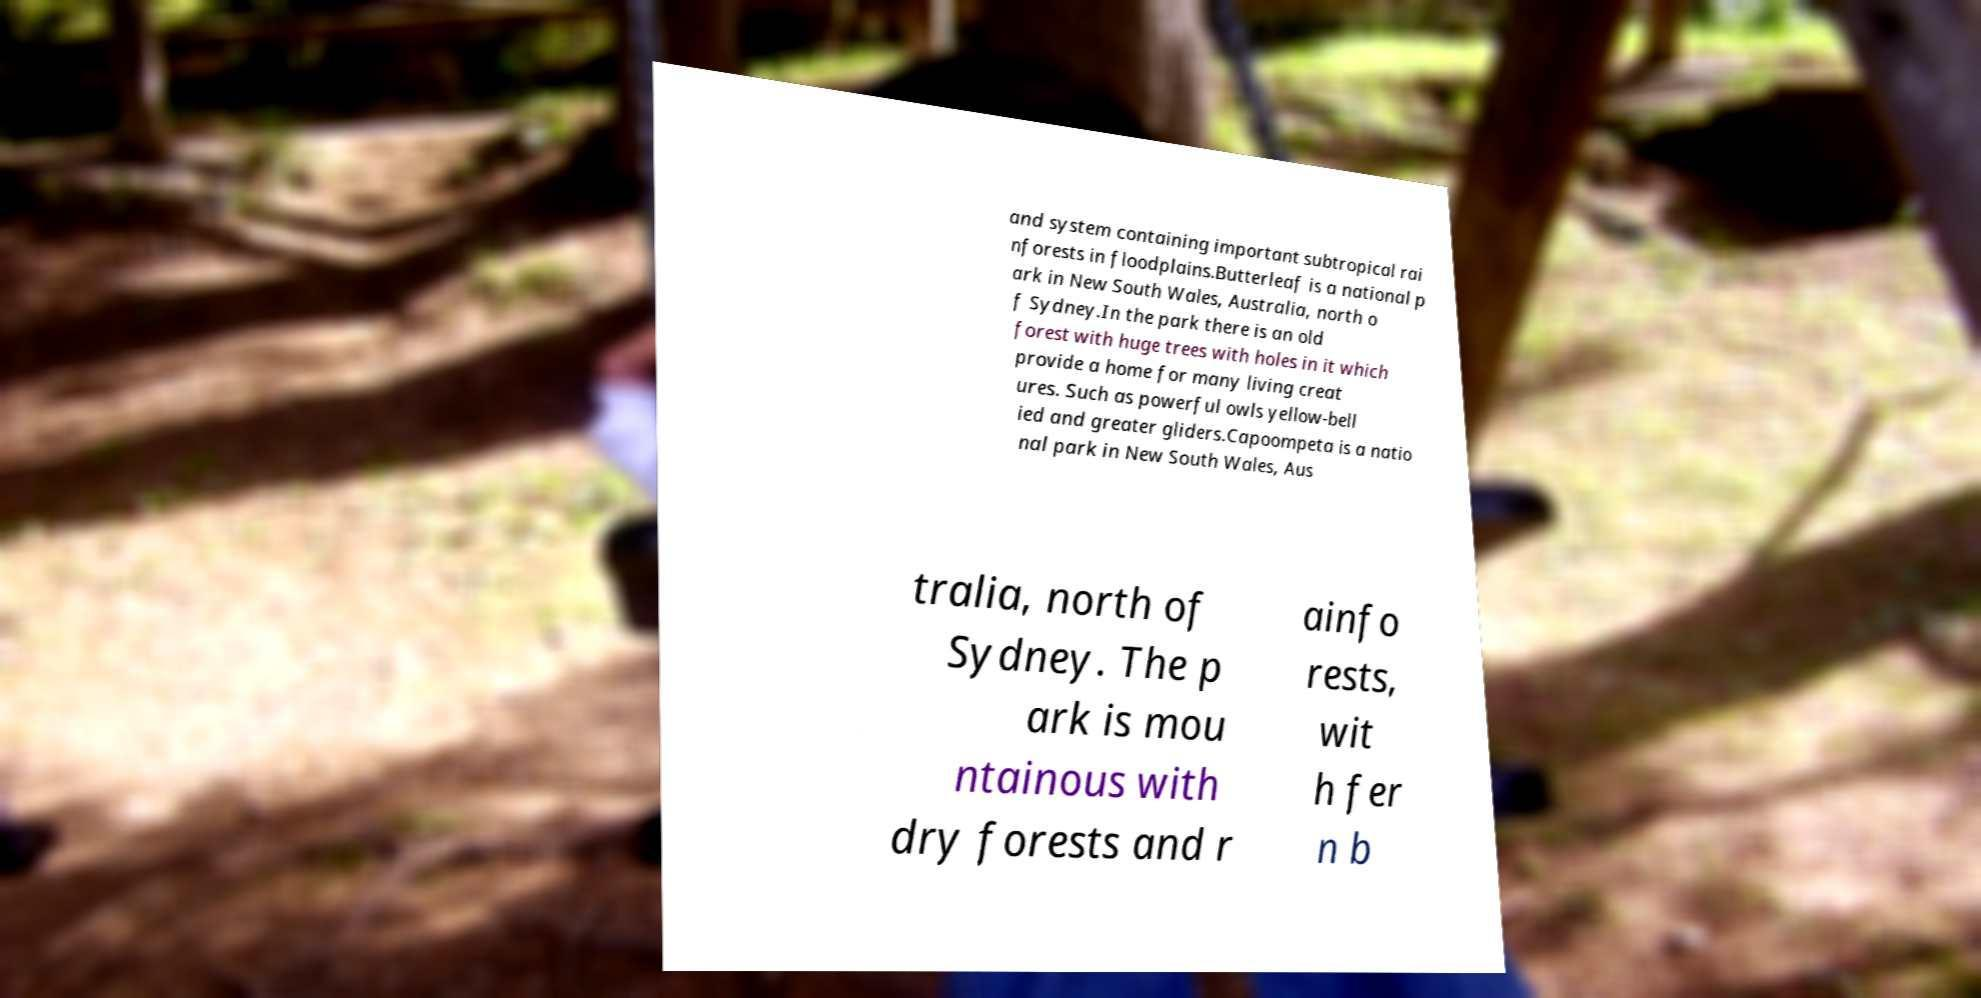Please read and relay the text visible in this image. What does it say? and system containing important subtropical rai nforests in floodplains.Butterleaf is a national p ark in New South Wales, Australia, north o f Sydney.In the park there is an old forest with huge trees with holes in it which provide a home for many living creat ures. Such as powerful owls yellow-bell ied and greater gliders.Capoompeta is a natio nal park in New South Wales, Aus tralia, north of Sydney. The p ark is mou ntainous with dry forests and r ainfo rests, wit h fer n b 